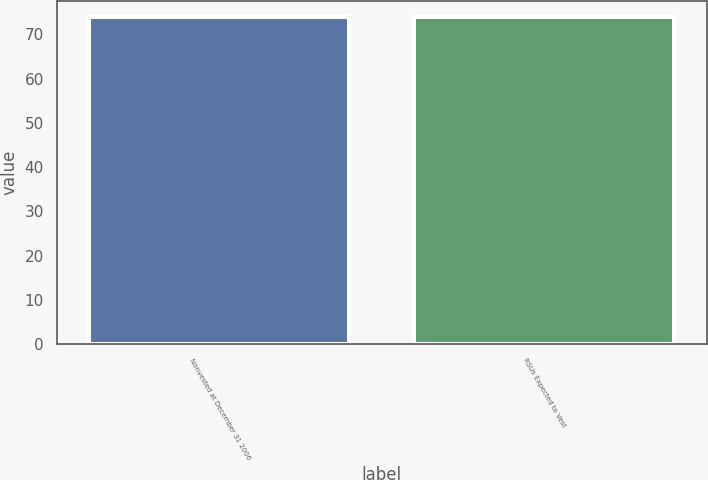<chart> <loc_0><loc_0><loc_500><loc_500><bar_chart><fcel>Nonvested at December 31 2006<fcel>RSUs Expected to Vest<nl><fcel>73.82<fcel>73.92<nl></chart> 